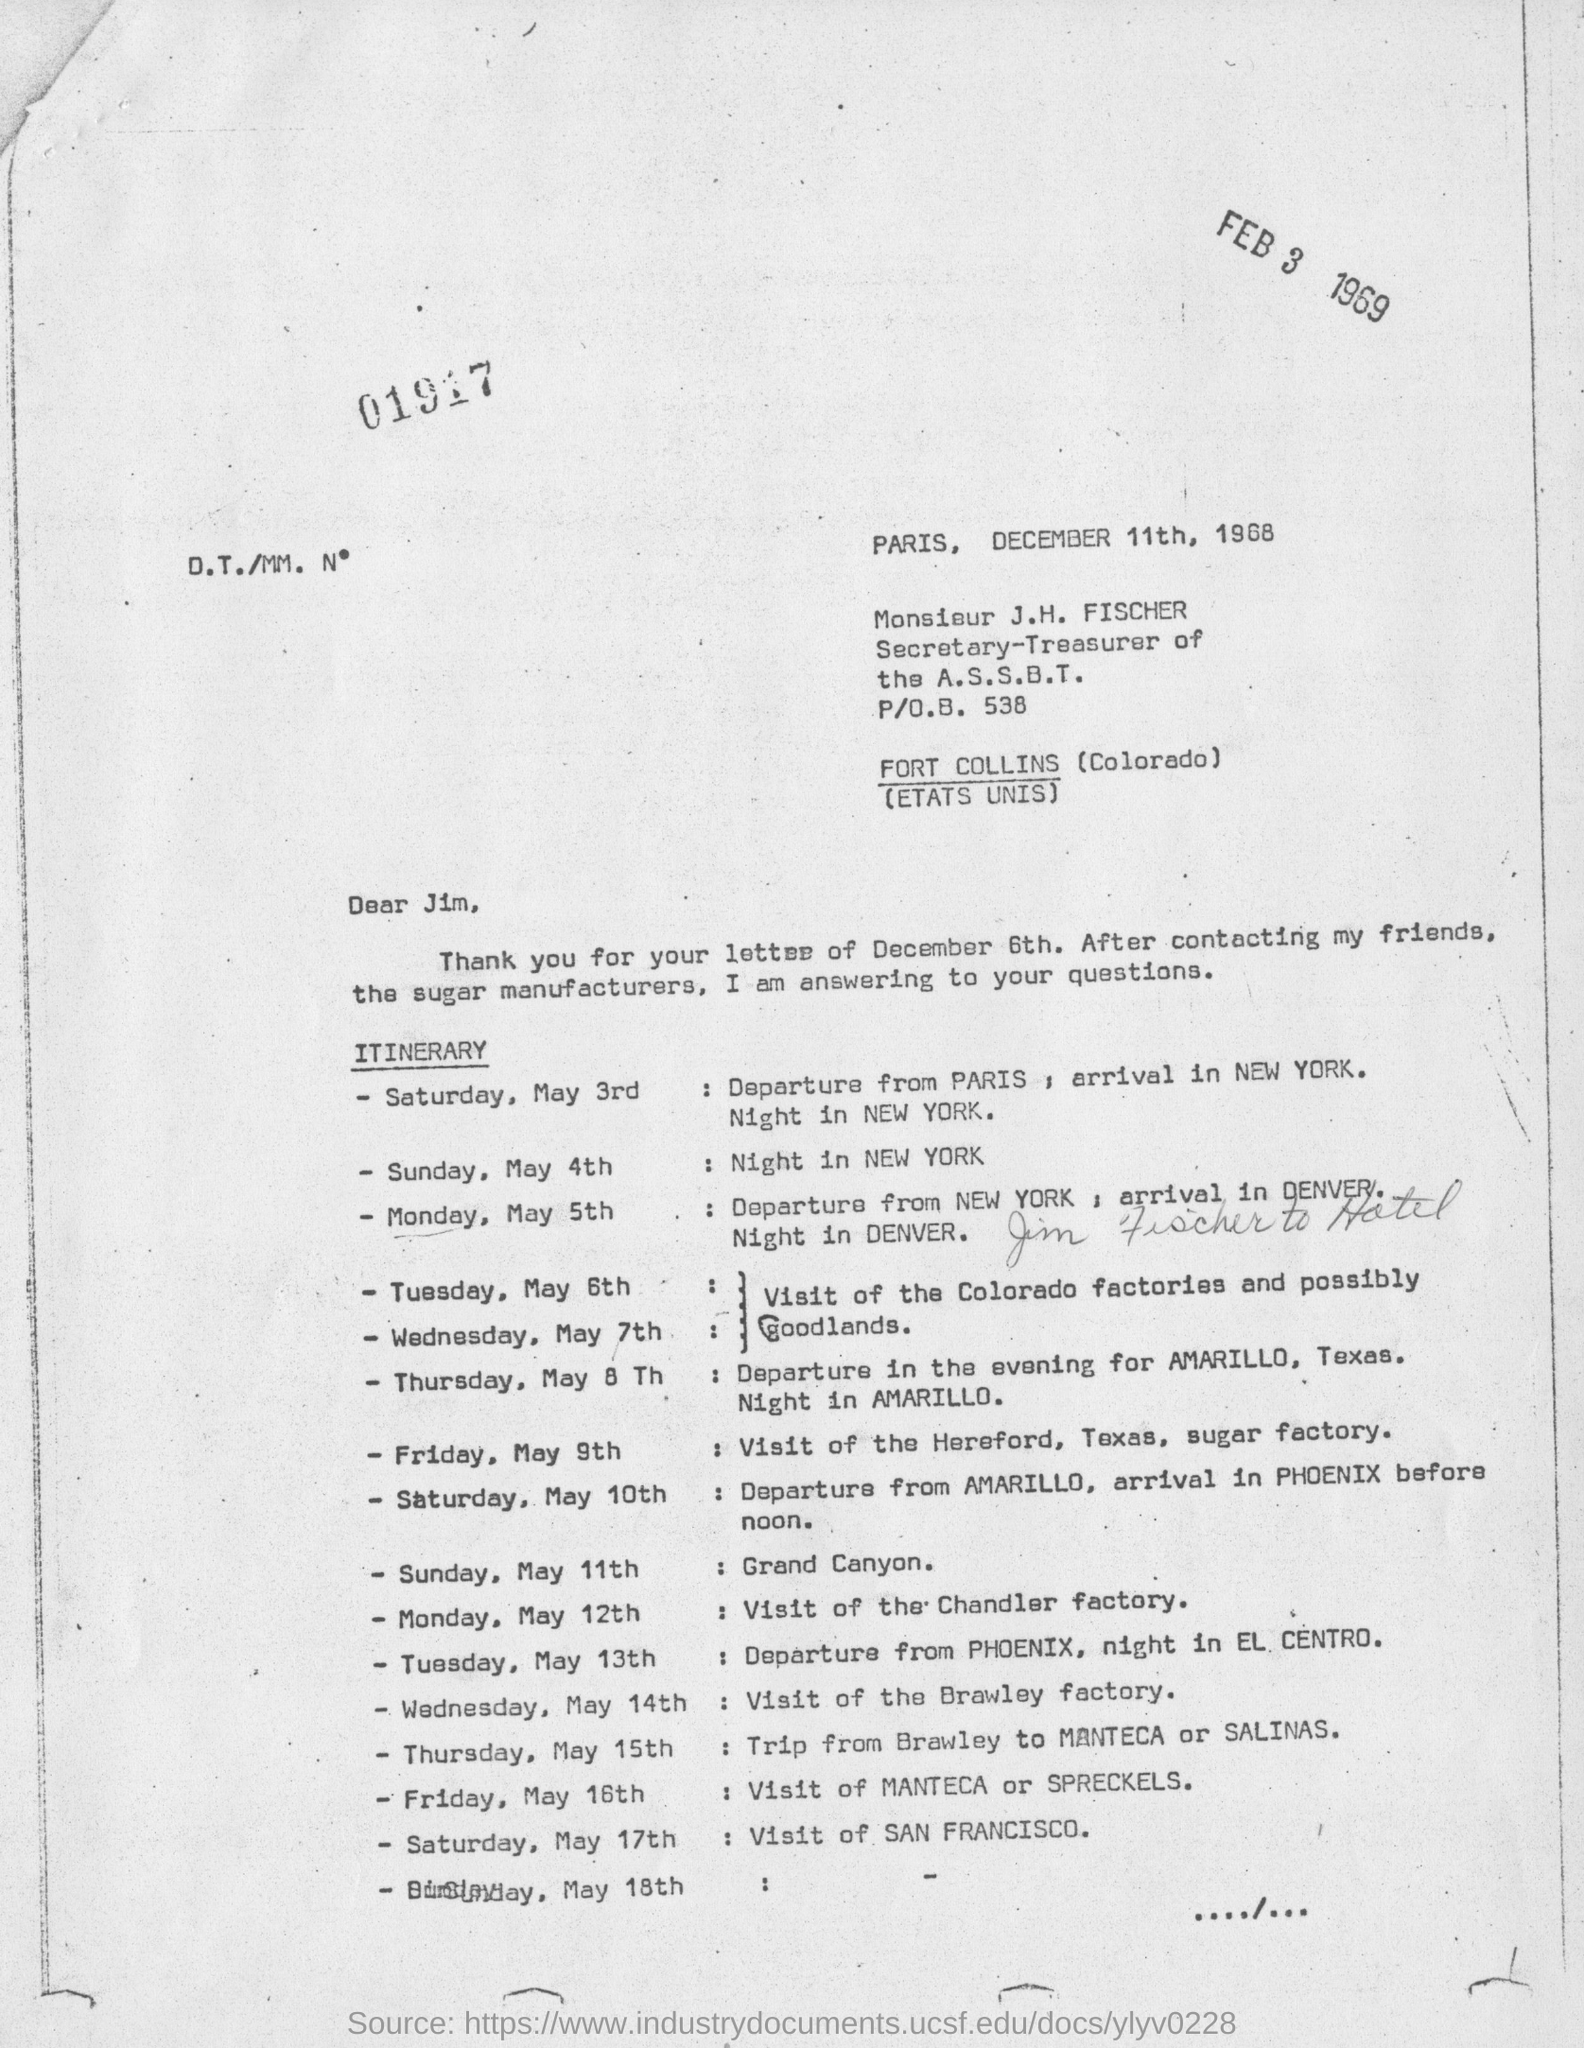When is the letter dated on?
Your response must be concise. DECEMBER 11TH, 1968. Where is the visit to on Sunday, May 11th?
Make the answer very short. GRAND CANYON. 